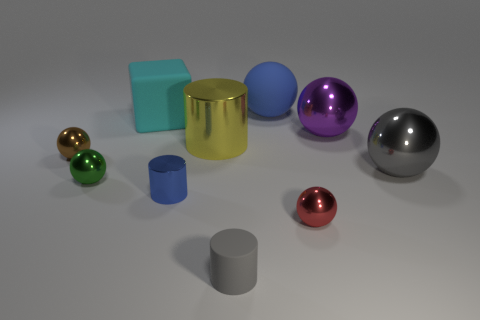There is a sphere that is the same color as the tiny rubber cylinder; what size is it?
Offer a very short reply. Large. Is the number of rubber objects that are in front of the small metallic cylinder greater than the number of blue matte balls that are on the left side of the gray cylinder?
Offer a terse response. Yes. What number of large blocks have the same color as the tiny rubber thing?
Offer a terse response. 0. There is a gray thing that is the same material as the tiny brown sphere; what size is it?
Offer a terse response. Large. What number of things are either cylinders behind the gray rubber object or cylinders?
Provide a short and direct response. 3. Is the color of the shiny cylinder that is in front of the brown metal object the same as the matte sphere?
Give a very brief answer. Yes. There is another matte object that is the same shape as the big purple thing; what size is it?
Keep it short and to the point. Large. There is a tiny cylinder that is in front of the blue thing in front of the blue object that is right of the small blue thing; what color is it?
Provide a succinct answer. Gray. Are the large cyan cube and the blue ball made of the same material?
Your answer should be compact. Yes. There is a cylinder on the left side of the large yellow cylinder left of the large purple metal object; is there a tiny metallic thing that is in front of it?
Offer a terse response. Yes. 